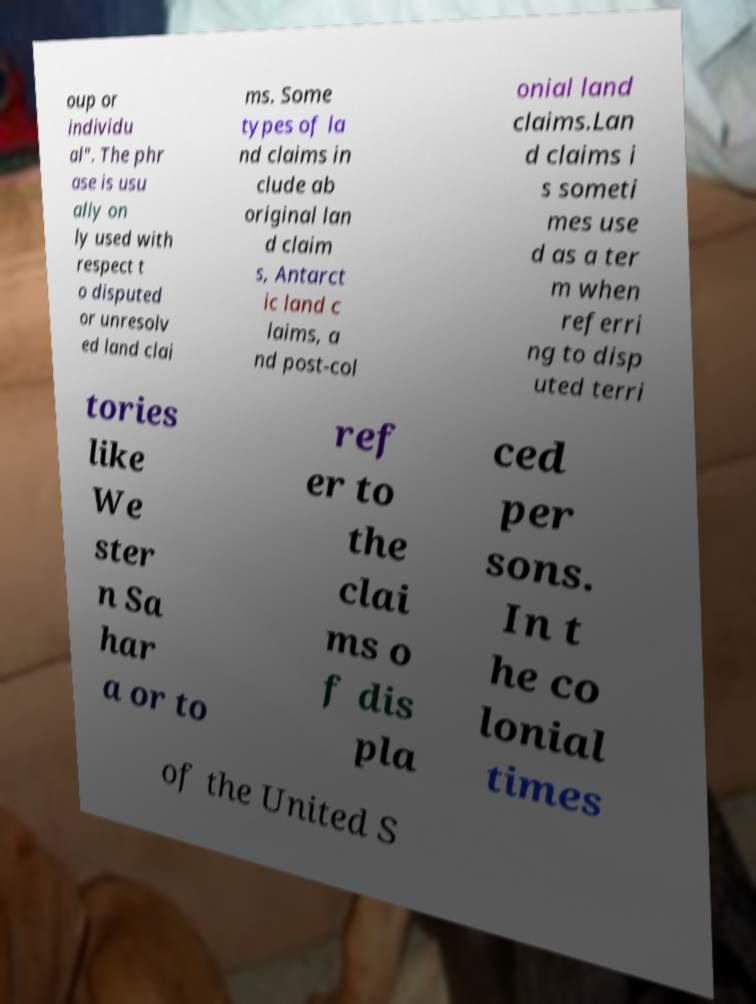Can you read and provide the text displayed in the image?This photo seems to have some interesting text. Can you extract and type it out for me? oup or individu al". The phr ase is usu ally on ly used with respect t o disputed or unresolv ed land clai ms. Some types of la nd claims in clude ab original lan d claim s, Antarct ic land c laims, a nd post-col onial land claims.Lan d claims i s someti mes use d as a ter m when referri ng to disp uted terri tories like We ster n Sa har a or to ref er to the clai ms o f dis pla ced per sons. In t he co lonial times of the United S 